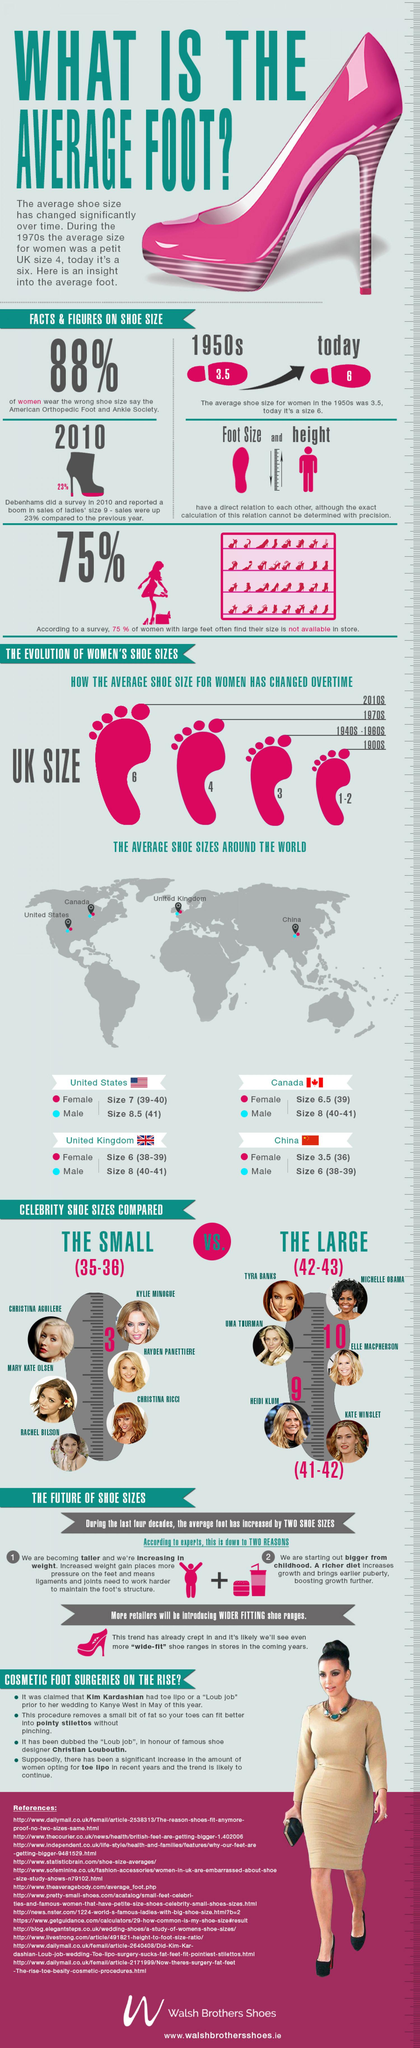Point out several critical features in this image. Michelle Obama's shoe size is reported to be large. The average shoe size for women has increased by 2.5 inches from the 1950s to today. There are 13 references that have been cited. A significant proportion of women with large feet are unable to find their size in stores, with 25% reporting this difficulty. In 2020, the average shoe size for women is approximately 6. 